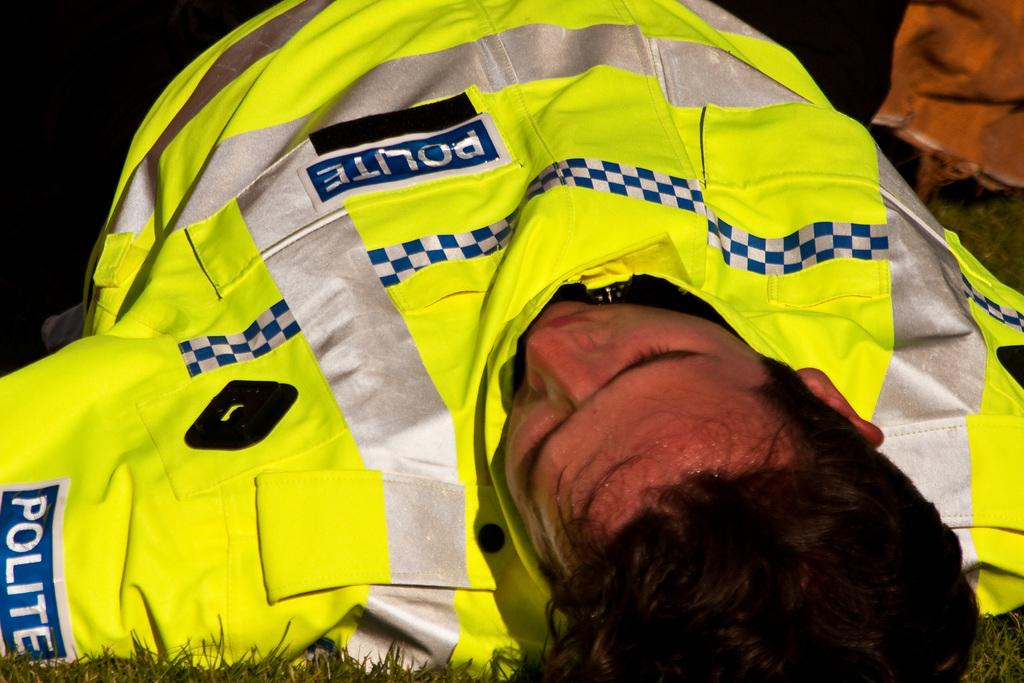Where was the image taken? The image is taken outdoors. What type of surface is visible in the image? There is a ground with grass in the image. What is the man in the image doing? The man is sleeping on the ground in the image. What type of vest is the man wearing in the image? The man is not wearing a vest in the image; he is sleeping on the ground with grass. What does the man need to do in the image? The image does not provide information about what the man needs to do; it only shows him sleeping on the ground with grass. 